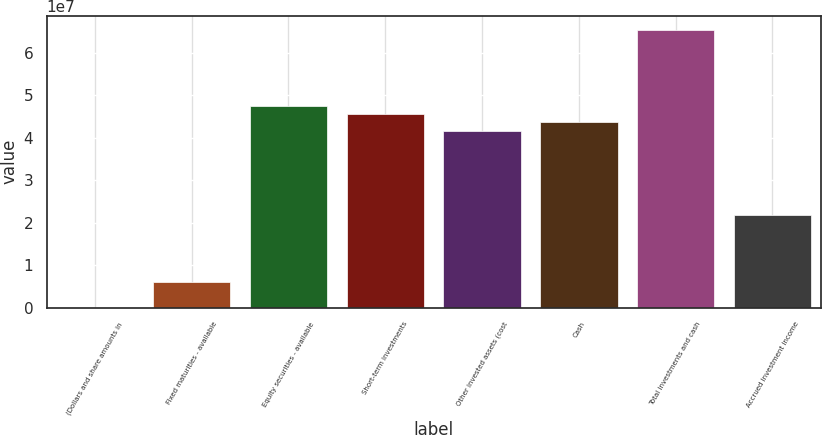<chart> <loc_0><loc_0><loc_500><loc_500><bar_chart><fcel>(Dollars and share amounts in<fcel>Fixed maturities - available<fcel>Equity securities - available<fcel>Short-term investments<fcel>Other invested assets (cost<fcel>Cash<fcel>Total investments and cash<fcel>Accrued investment income<nl><fcel>2013<fcel>5.94382e+06<fcel>4.75365e+07<fcel>4.55559e+07<fcel>4.15947e+07<fcel>4.35753e+07<fcel>6.53619e+07<fcel>2.17886e+07<nl></chart> 